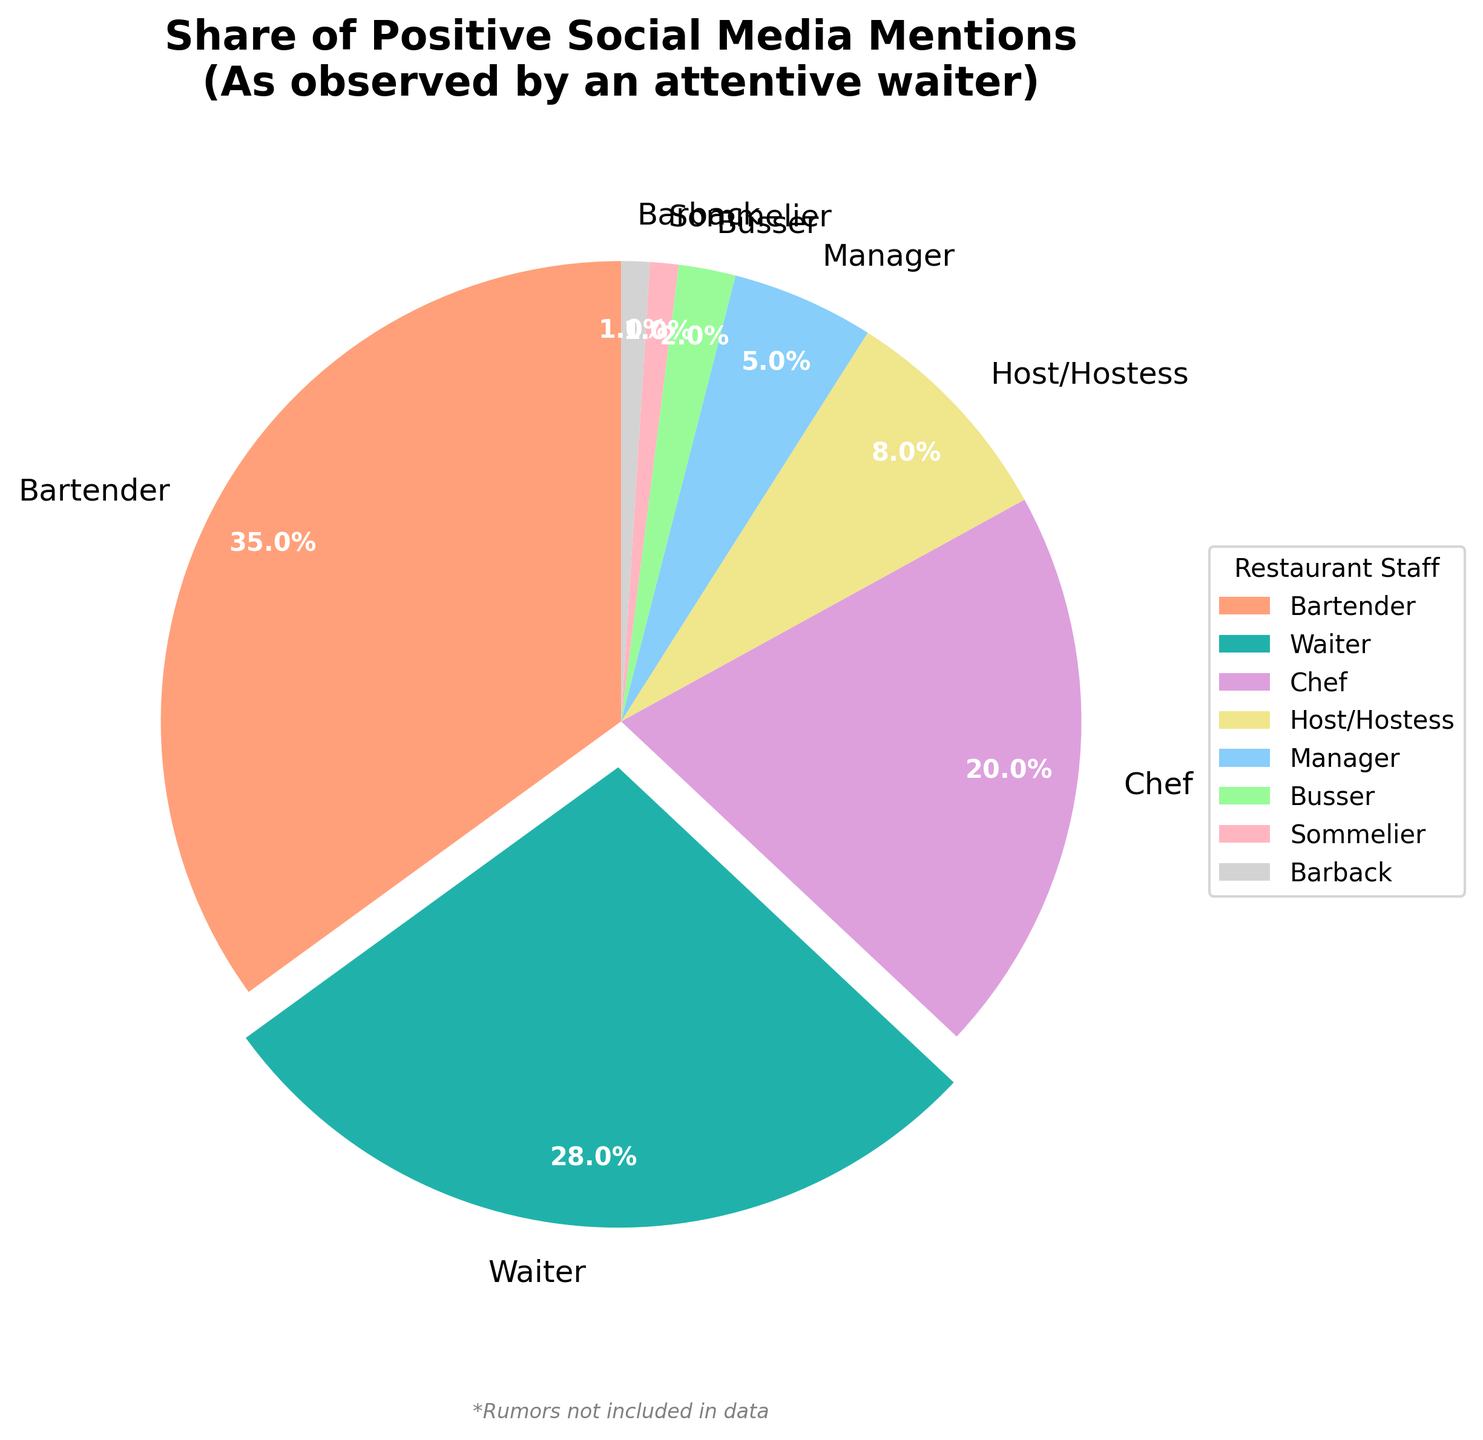What percentage of positive mentions does the waiter receive compared to the bartender? The waiter receives 28% of positive mentions, while the bartender receives 35%. To find the comparison, simply look at their respective percentages on the pie chart.
Answer: The waiter receives 28%, while the bartender gets 35% Which role has the least share of positive social media mentions? The pie chart shows that both the sommelier and barback each have only 1% share of positive mentions, which are the lowest percentages.
Answer: Sommelier and Barback How much higher is the percentage of positive mentions for the chef compared to the host/hostess? The chef has 20% and the host/hostess has 8%. Subtract the host/hostess’s percentage from the chef’s percentage: 20% - 8% = 12%. The chef's share is 12% higher.
Answer: 12% What is the combined percentage of positive mentions received by the manager, busser, sommelier, and barback? Add the percentages for the manager (5%), busser (2%), sommelier (1%), and barback (1%): 5% + 2% + 1% + 1% = 9%. The combined share is 9%.
Answer: 9% If you combine the percentages of the host/hostess and manager, how do they compare to the waiter's percentage? The host/hostess has 8% and the manager has 5%. Combined, they have 8% + 5% = 13%. The waiter has 28%. Comparing, 28% (Waiter) is much higher than 13% (Host/Hostess + Manager).
Answer: 28% is much higher than 13% Which roles have percentages below 10%? The roles with percentages below 10% are Host/Hostess (8%), Manager (5%), Busser (2%), Sommelier (1%), and Barback (1%). Simply check each role in the pie chart to verify.
Answer: Host/Hostess, Manager, Busser, Sommelier, Barback What visual element in the pie chart emphasizes the waiter's share of positive mentions? The waiter's slice of the pie chart is slightly separated (exploded) from the rest and uses a distinct color to focus on its share of positive mentions.
Answer: Exploded slice and distinct color What is the average percentage of positive mentions for all roles combined? The percentages are 35, 28, 20, 8, 5, 2, 1, and 1. First, sum them: 35 + 28 + 20 + 8 + 5 + 2 + 1 + 1 = 100. There are 8 roles: 100 / 8 = 12.5. The average is 12.5%.
Answer: 12.5% How many roles have a higher percentage of positive mentions than the manager? The percentages are: Bartender (35), Waiter (28), Chef (20), Host/Hostess (8). These are the roles higher than the manager (5%). There are 4 such roles.
Answer: 4 